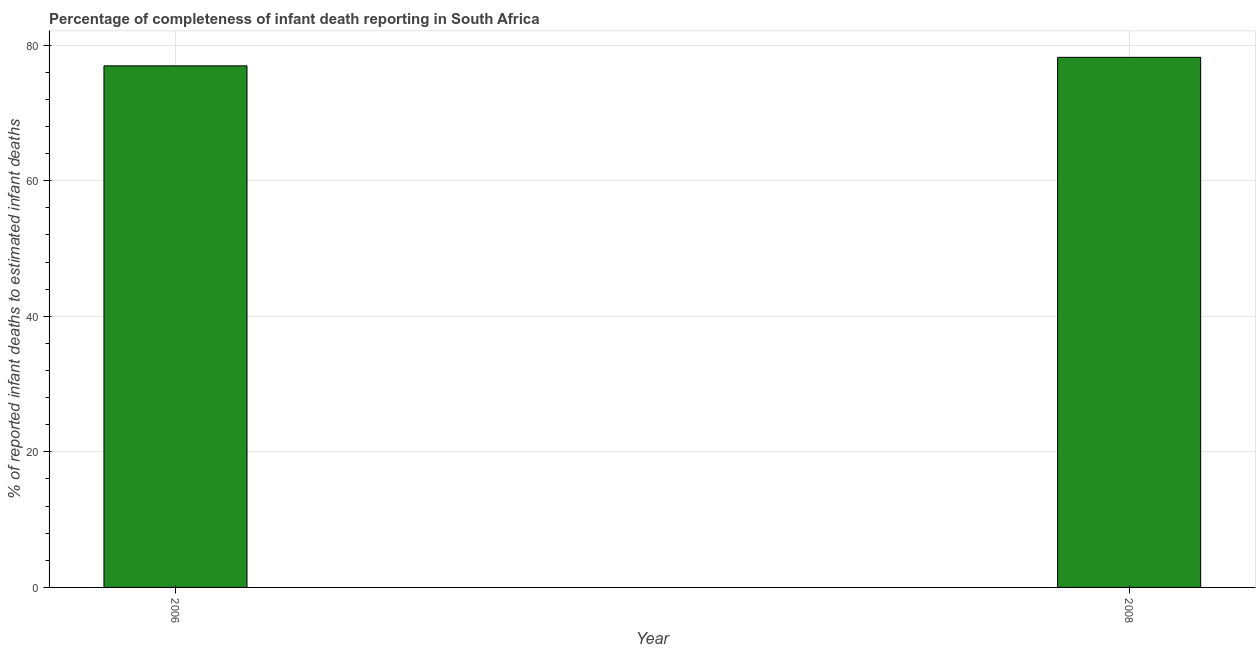Does the graph contain grids?
Your answer should be very brief. Yes. What is the title of the graph?
Give a very brief answer. Percentage of completeness of infant death reporting in South Africa. What is the label or title of the X-axis?
Make the answer very short. Year. What is the label or title of the Y-axis?
Make the answer very short. % of reported infant deaths to estimated infant deaths. What is the completeness of infant death reporting in 2006?
Your response must be concise. 76.96. Across all years, what is the maximum completeness of infant death reporting?
Your answer should be compact. 78.21. Across all years, what is the minimum completeness of infant death reporting?
Provide a short and direct response. 76.96. In which year was the completeness of infant death reporting maximum?
Your response must be concise. 2008. In which year was the completeness of infant death reporting minimum?
Keep it short and to the point. 2006. What is the sum of the completeness of infant death reporting?
Provide a short and direct response. 155.17. What is the difference between the completeness of infant death reporting in 2006 and 2008?
Your response must be concise. -1.26. What is the average completeness of infant death reporting per year?
Provide a short and direct response. 77.58. What is the median completeness of infant death reporting?
Offer a terse response. 77.58. In how many years, is the completeness of infant death reporting greater than 24 %?
Make the answer very short. 2. How many bars are there?
Offer a terse response. 2. What is the % of reported infant deaths to estimated infant deaths in 2006?
Offer a terse response. 76.96. What is the % of reported infant deaths to estimated infant deaths in 2008?
Your answer should be compact. 78.21. What is the difference between the % of reported infant deaths to estimated infant deaths in 2006 and 2008?
Give a very brief answer. -1.26. What is the ratio of the % of reported infant deaths to estimated infant deaths in 2006 to that in 2008?
Your response must be concise. 0.98. 